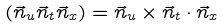Convert formula to latex. <formula><loc_0><loc_0><loc_500><loc_500>( \vec { n } _ { u } \vec { n } _ { t } \vec { n } _ { x } ) = \vec { n } _ { u } \times \vec { n } _ { t } \cdot \vec { n } _ { x }</formula> 